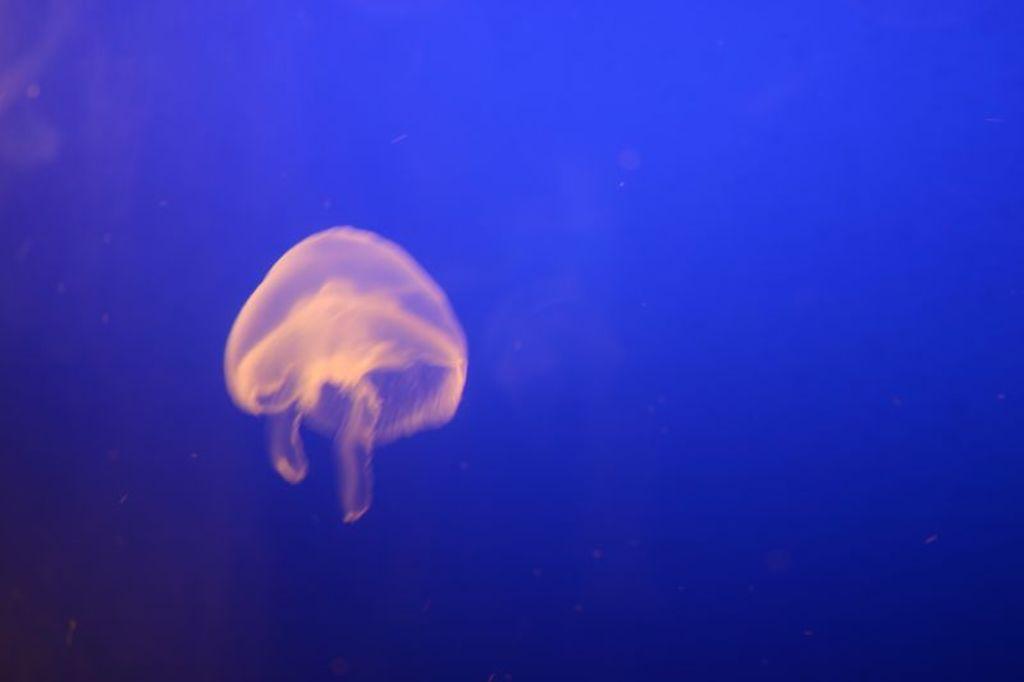How would you summarize this image in a sentence or two? In the center of the image we can see one jellyfish in the water. And we can see, jellyfish is in cream color. And we can see the blue color background. 